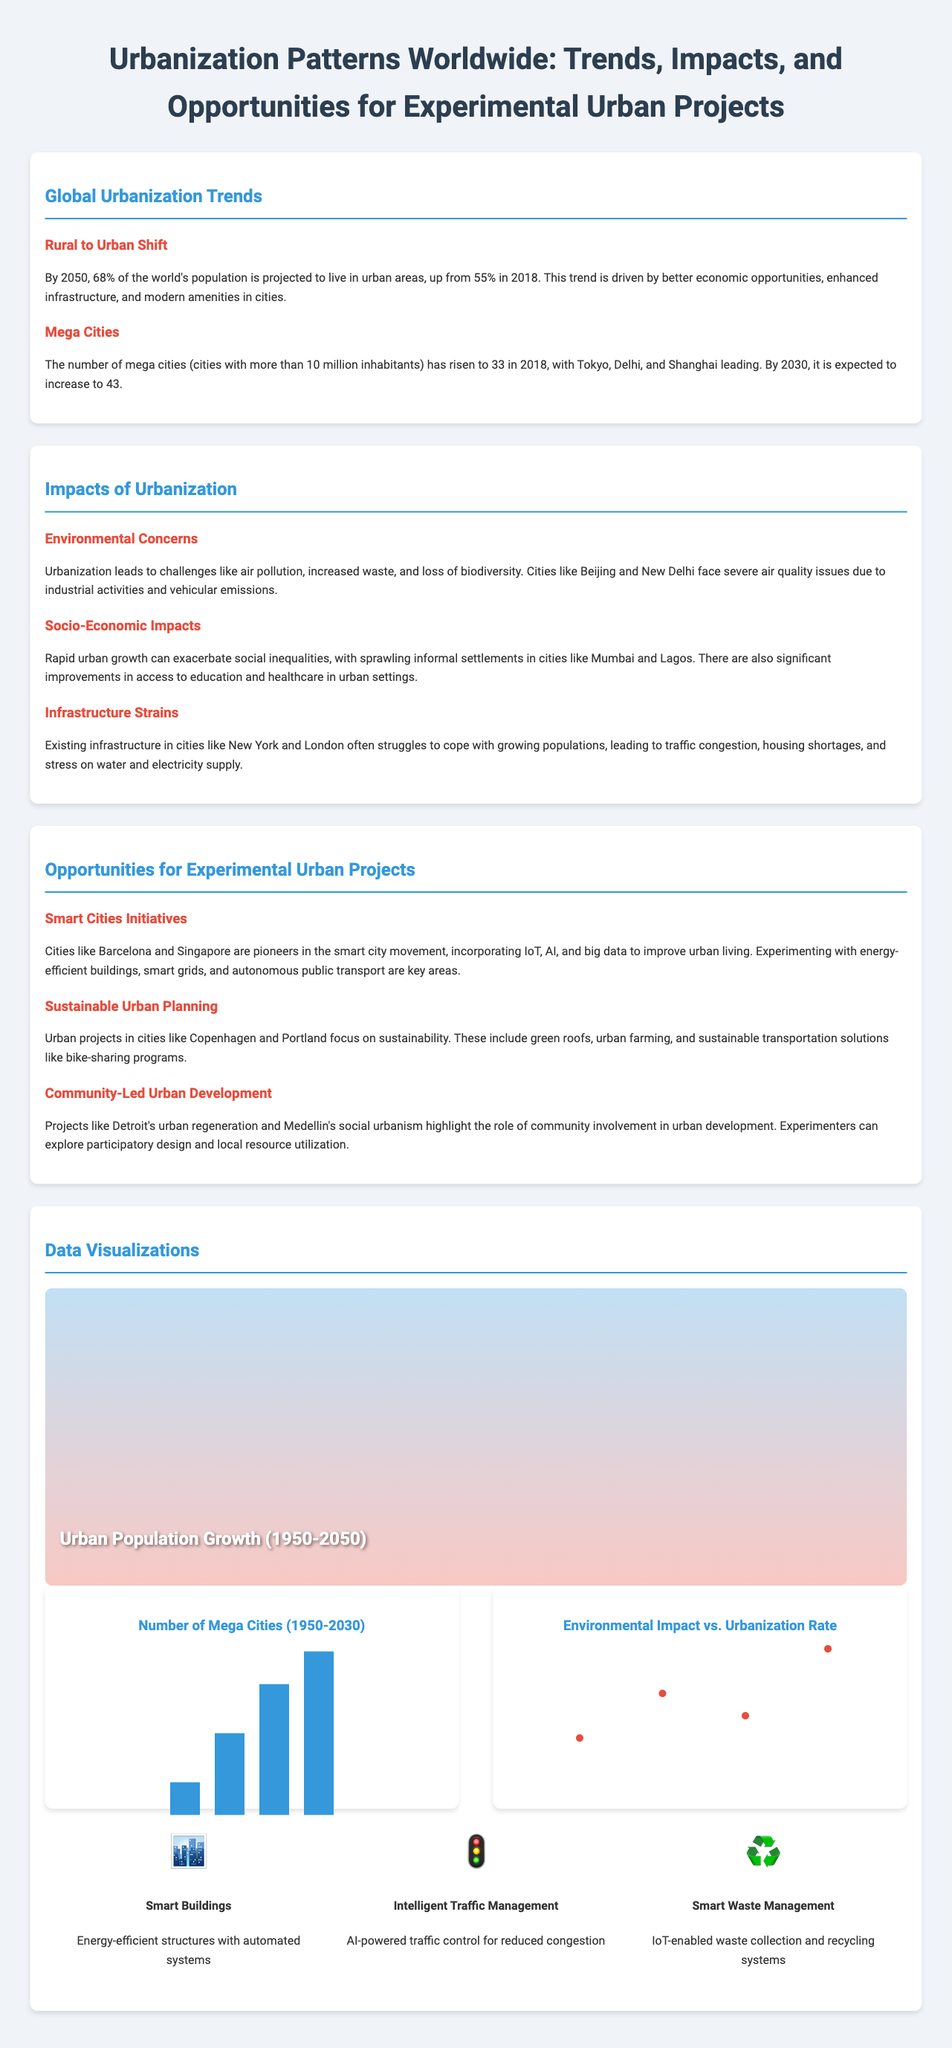what percentage of the world's population is projected to live in urban areas by 2050? The document states that by 2050, 68% of the world's population is expected to live in urban areas.
Answer: 68% how many mega cities were there in 2018? According to the document, the number of mega cities in 2018 rose to 33.
Answer: 33 which city is a pioneer in smart city initiatives? The document mentions Barcelona as a pioneer in smart city initiatives.
Answer: Barcelona what type of impact does urbanization have on air quality? The document states that urbanization leads to challenges like air pollution.
Answer: Air pollution what is one opportunity mentioned for sustainable urban planning? An example given in the document is urban farming as an opportunity for sustainable urban planning.
Answer: Urban farming which two cities face severe air quality issues due to urbanization? The document lists Beijing and New Delhi as cities facing severe air quality issues.
Answer: Beijing and New Delhi how many mega cities are expected by 2030? The document indicates that the number of mega cities is expected to increase to 43 by 2030.
Answer: 43 what is a key feature of smart waste management? The document describes smart waste management as being IoT-enabled.
Answer: IoT-enabled how do community-led urban projects like Detroit's impact urban development? Community-led urban projects highlight the role of community involvement in urban development.
Answer: Community involvement 